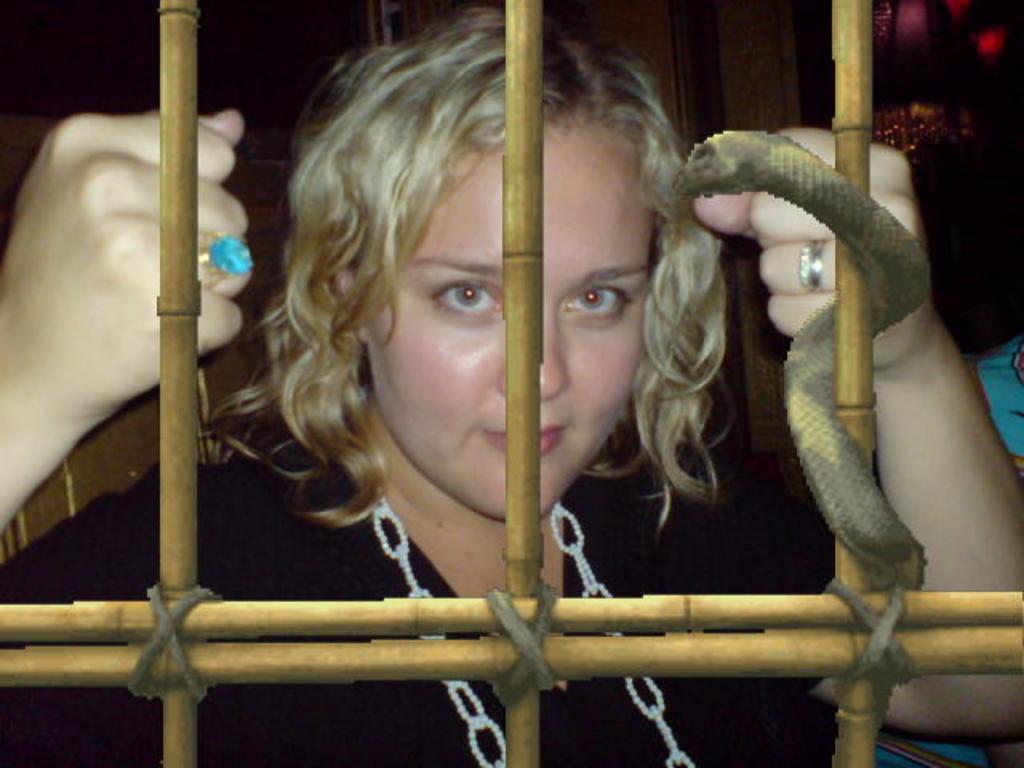In one or two sentences, can you explain what this image depicts? In this image we can see there is a woman wearing blue ring on the right hand and wearing a black dress. 